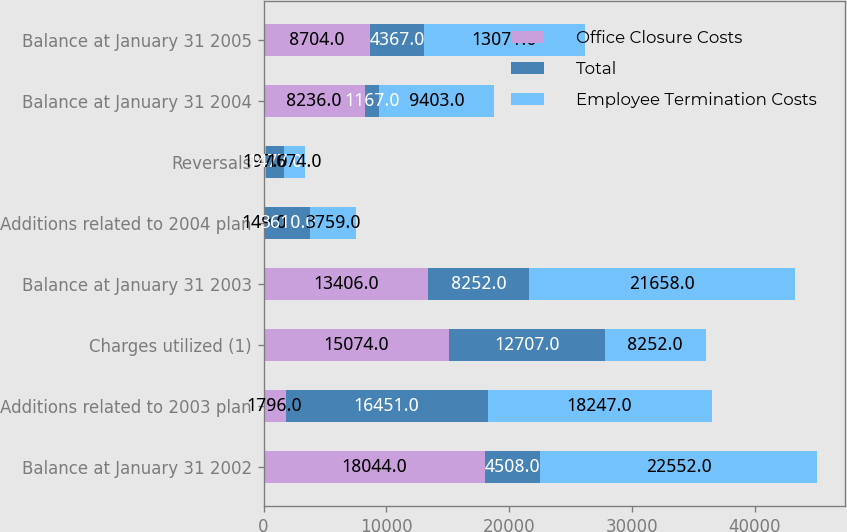Convert chart to OTSL. <chart><loc_0><loc_0><loc_500><loc_500><stacked_bar_chart><ecel><fcel>Balance at January 31 2002<fcel>Additions related to 2003 plan<fcel>Charges utilized (1)<fcel>Balance at January 31 2003<fcel>Additions related to 2004 plan<fcel>Reversals<fcel>Balance at January 31 2004<fcel>Balance at January 31 2005<nl><fcel>Office Closure Costs<fcel>18044<fcel>1796<fcel>15074<fcel>13406<fcel>149<fcel>197<fcel>8236<fcel>8704<nl><fcel>Total<fcel>4508<fcel>16451<fcel>12707<fcel>8252<fcel>3610<fcel>1477<fcel>1167<fcel>4367<nl><fcel>Employee Termination Costs<fcel>22552<fcel>18247<fcel>8252<fcel>21658<fcel>3759<fcel>1674<fcel>9403<fcel>13071<nl></chart> 